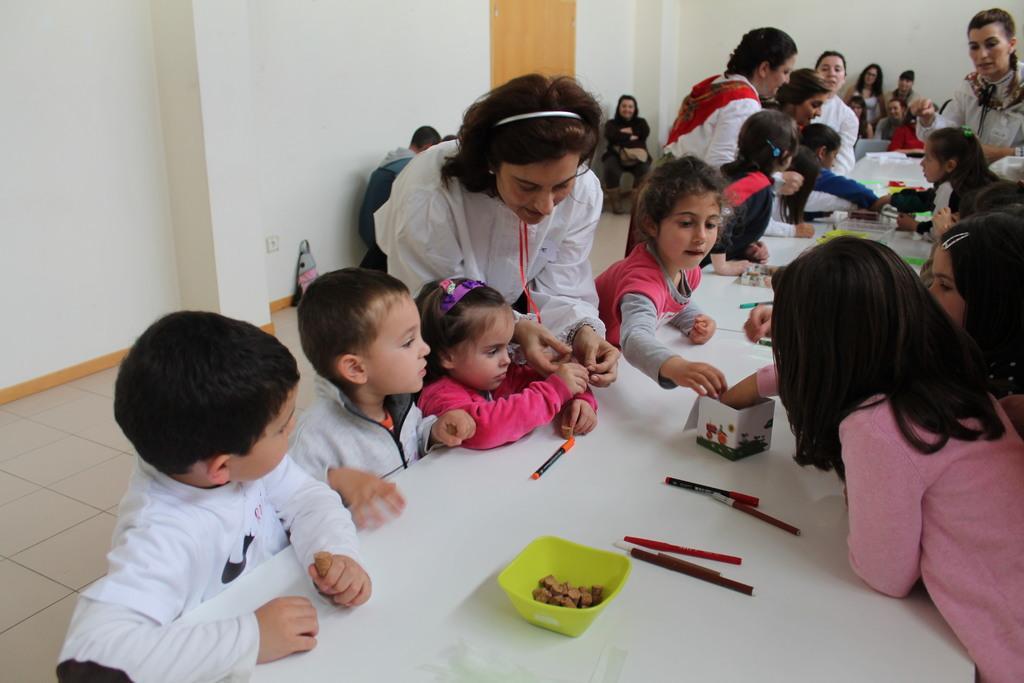Could you give a brief overview of what you see in this image? In this image we can see a group of children standing in front of a table. In the background, we can see group of people. One woman is wearing a headband and a white shirt.. One person is sitting on a chair. On the table we can see a group of pens and bowl containing food and a bag placed on the floor. 